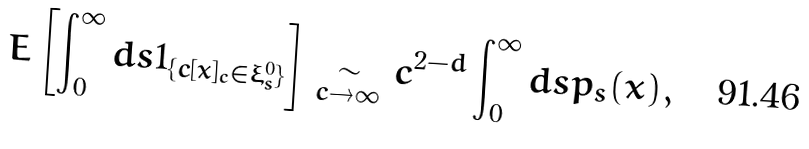Convert formula to latex. <formula><loc_0><loc_0><loc_500><loc_500>E \left [ \int _ { 0 } ^ { \infty } d s 1 _ { \{ c [ x ] _ { c } \in \xi _ { s } ^ { 0 } \} } \right ] \underset { c \to \infty } { \sim } c ^ { 2 - d } \int _ { 0 } ^ { \infty } d s p _ { s } ( x ) ,</formula> 